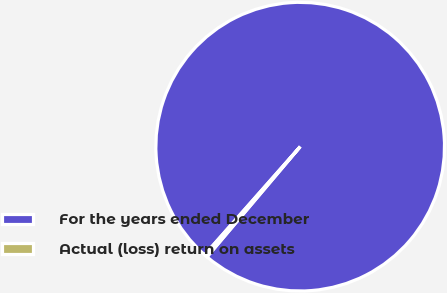Convert chart. <chart><loc_0><loc_0><loc_500><loc_500><pie_chart><fcel>For the years ended December<fcel>Actual (loss) return on assets<nl><fcel>99.65%<fcel>0.35%<nl></chart> 